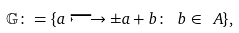Convert formula to latex. <formula><loc_0><loc_0><loc_500><loc_500>\mathbb { G } \colon = \{ a \longmapsto \pm a + b \colon \ b \in \ A \} ,</formula> 